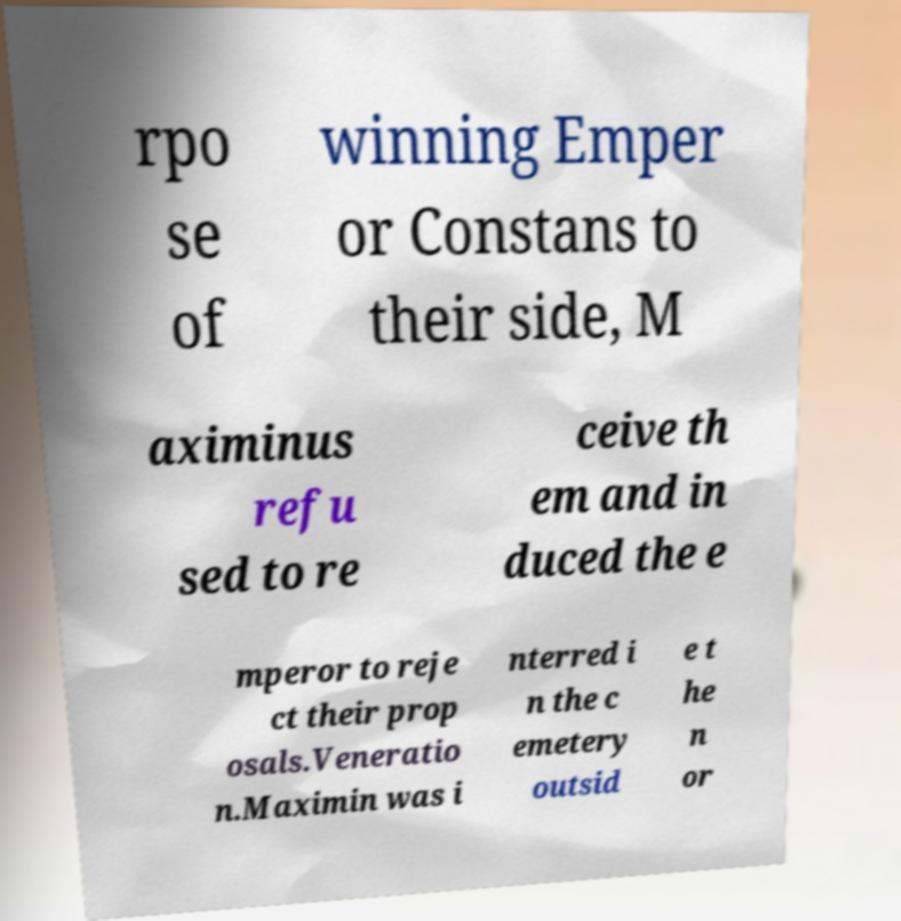Please identify and transcribe the text found in this image. rpo se of winning Emper or Constans to their side, M aximinus refu sed to re ceive th em and in duced the e mperor to reje ct their prop osals.Veneratio n.Maximin was i nterred i n the c emetery outsid e t he n or 